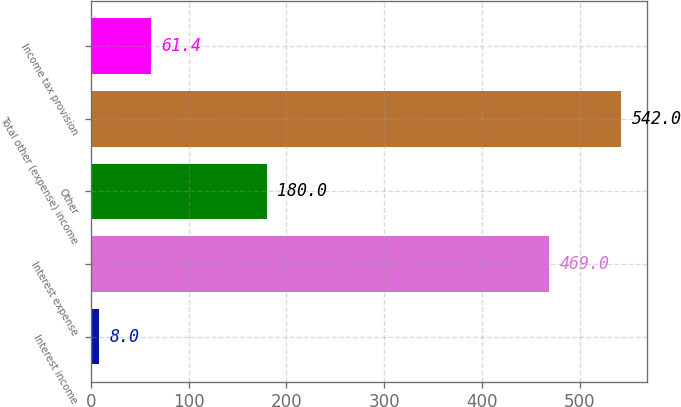Convert chart to OTSL. <chart><loc_0><loc_0><loc_500><loc_500><bar_chart><fcel>Interest income<fcel>Interest expense<fcel>Other<fcel>Total other (expense) income<fcel>Income tax provision<nl><fcel>8<fcel>469<fcel>180<fcel>542<fcel>61.4<nl></chart> 